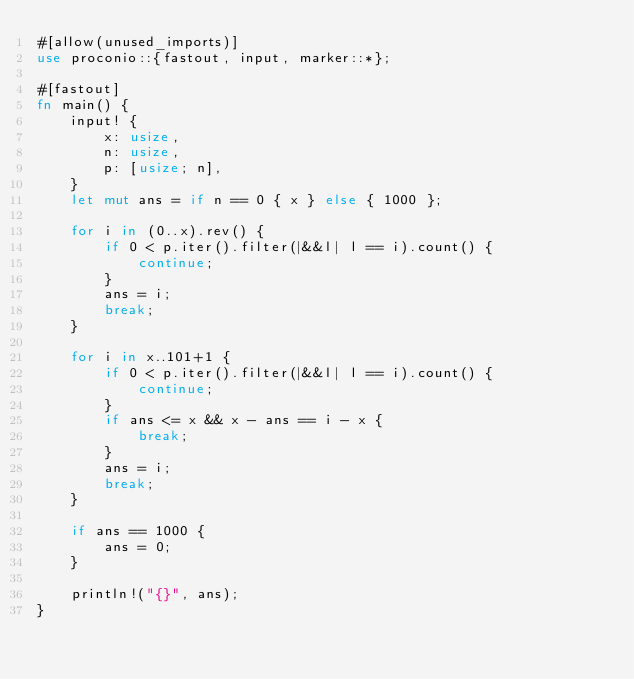Convert code to text. <code><loc_0><loc_0><loc_500><loc_500><_Rust_>#[allow(unused_imports)]
use proconio::{fastout, input, marker::*};

#[fastout]
fn main() {
    input! {
        x: usize,
        n: usize,
        p: [usize; n],
    }
    let mut ans = if n == 0 { x } else { 1000 };

    for i in (0..x).rev() {
        if 0 < p.iter().filter(|&&l| l == i).count() {
            continue;
        }
        ans = i;
        break;
    }

    for i in x..101+1 {
        if 0 < p.iter().filter(|&&l| l == i).count() {
            continue;
        }
        if ans <= x && x - ans == i - x {
            break;
        }
        ans = i;
        break;
    }

    if ans == 1000 {
        ans = 0;
    }

    println!("{}", ans);
}
</code> 